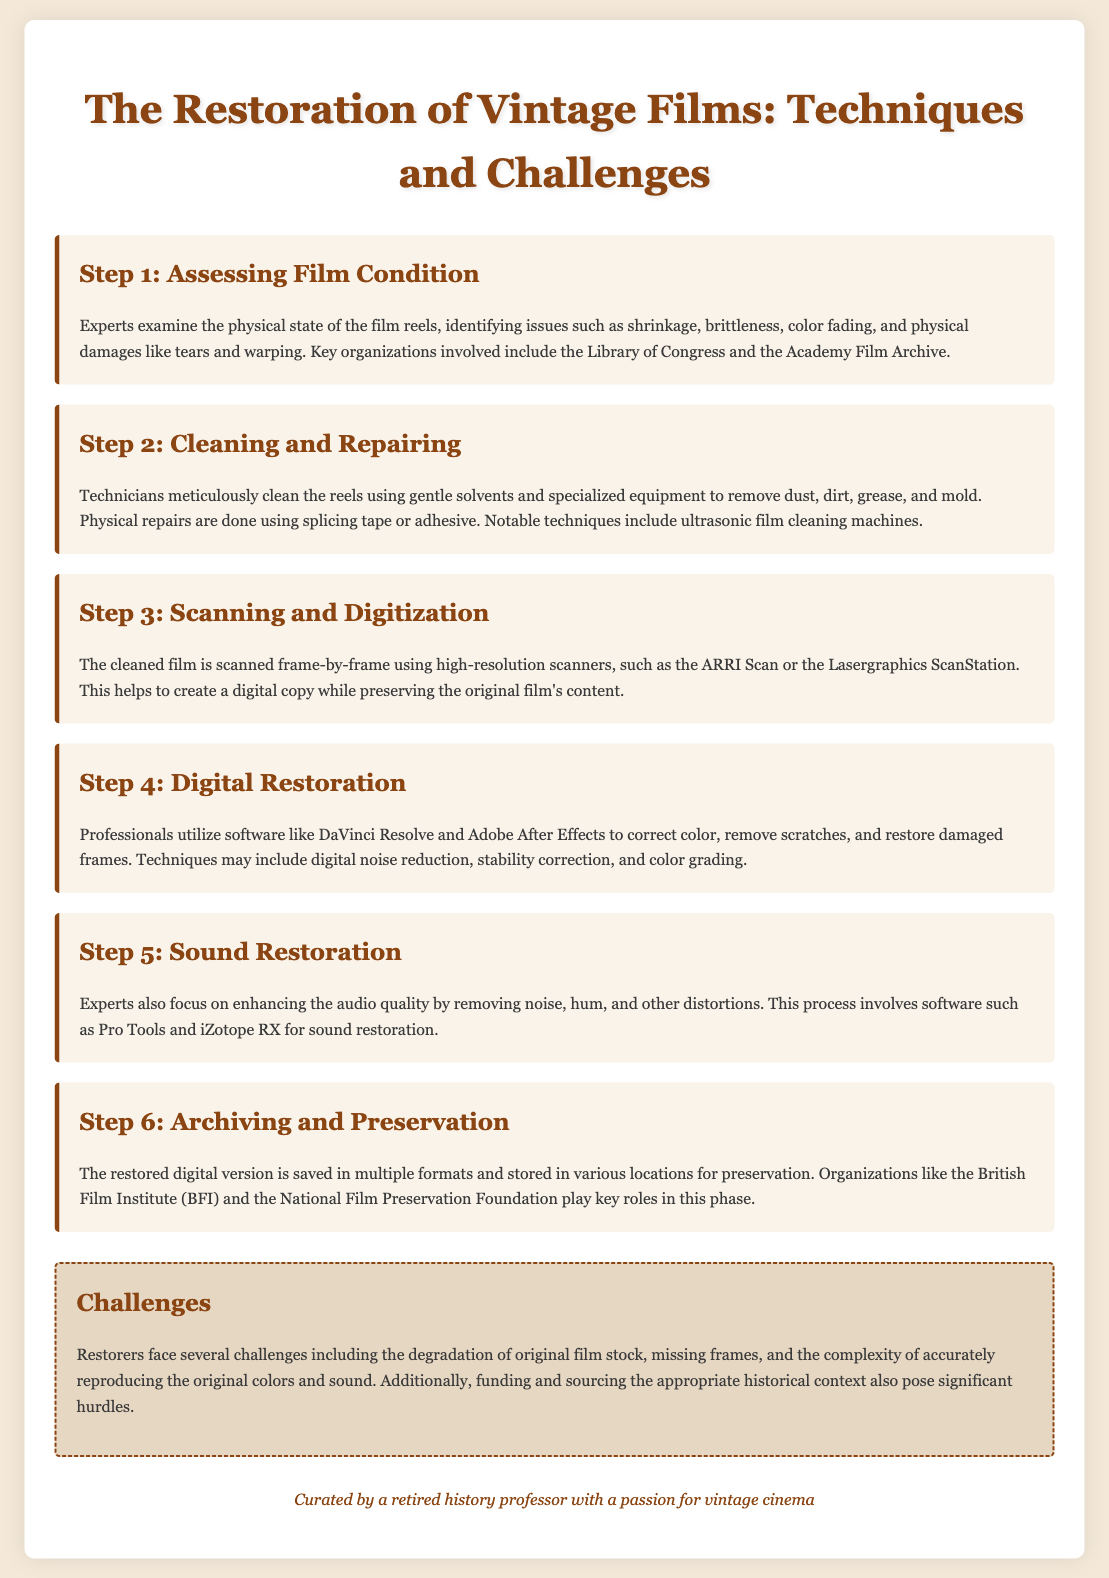What is the first step in the restoration process? The first step involves assessing the physical state of the film reels, including identifying issues such as shrinkage and brittleness.
Answer: Assessing Film Condition Which organization is involved in assessing film condition? Notable organizations mentioned include the Library of Congress and the Academy Film Archive.
Answer: Library of Congress What technique is used for cleaning film reels? One notable technique mentioned for cleaning is the use of ultrasonic film cleaning machines.
Answer: Ultrasonic film cleaning machines What software is utilized for digital restoration? Professionals use software such as DaVinci Resolve and Adobe After Effects for the digital restoration of films.
Answer: DaVinci Resolve and Adobe After Effects What is a major challenge in film restoration? A significant challenge faced by restorers is the degradation of original film stock.
Answer: Degradation of original film stock How many steps are outlined in the restoration process? There are a total of six steps described in the restoration process for vintage films.
Answer: Six steps What is done during the sound restoration step? During sound restoration, experts focus on enhancing audio quality by removing noise, hum, and distortions.
Answer: Enhancing audio quality Which organization is responsible for archiving and preservation mentioned in the document? The British Film Institute (BFI) is mentioned as a key organization in the archiving and preservation phase.
Answer: British Film Institute (BFI) 